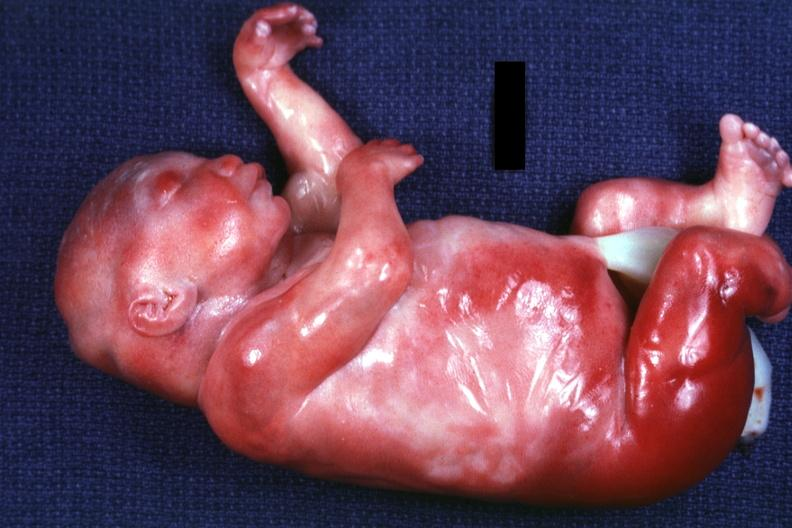do a barely seen vascular mass extruding from occipital region of skull arms and legs appear too short has six digits?
Answer the question using a single word or phrase. Yes 